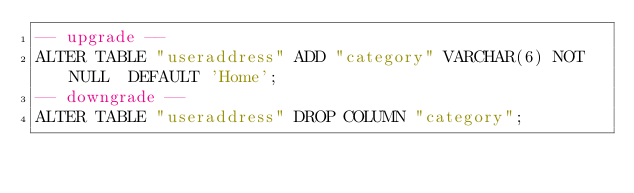Convert code to text. <code><loc_0><loc_0><loc_500><loc_500><_SQL_>-- upgrade --
ALTER TABLE "useraddress" ADD "category" VARCHAR(6) NOT NULL  DEFAULT 'Home';
-- downgrade --
ALTER TABLE "useraddress" DROP COLUMN "category";
</code> 